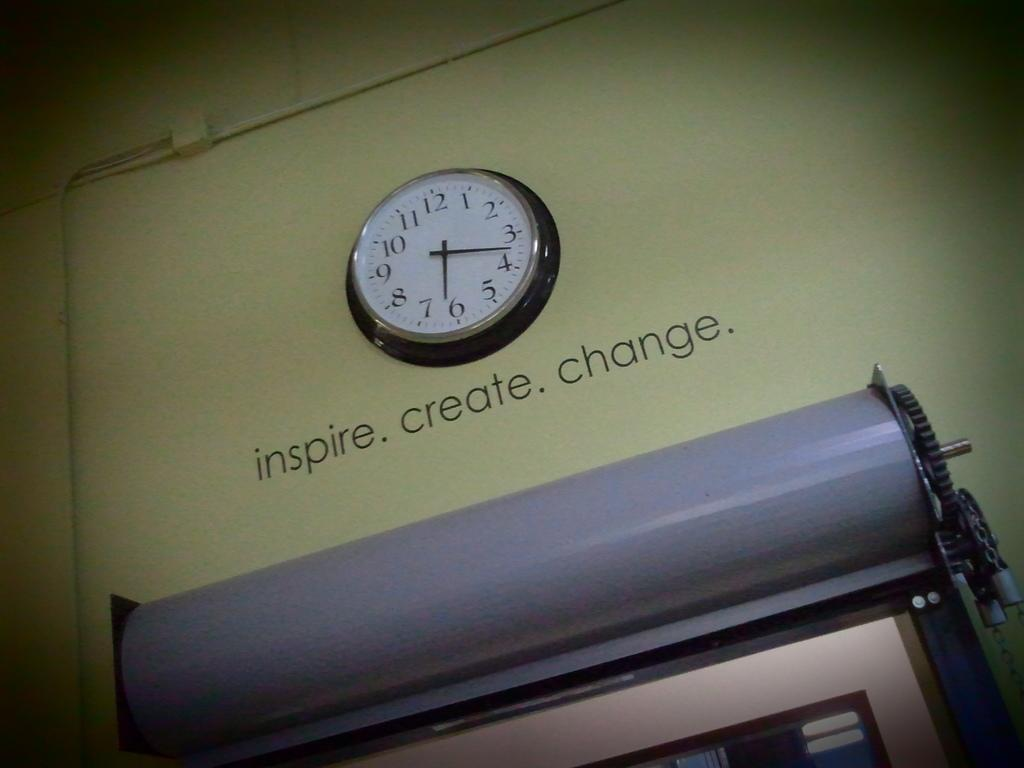<image>
Relay a brief, clear account of the picture shown. A clock at 6:17 on a tan wall with the words inspire. create, change on the wall under the clock. 